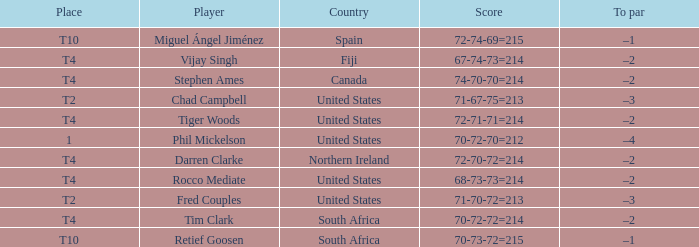What country is Chad Campbell from? United States. 